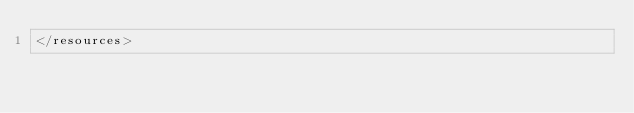<code> <loc_0><loc_0><loc_500><loc_500><_XML_></resources>
</code> 